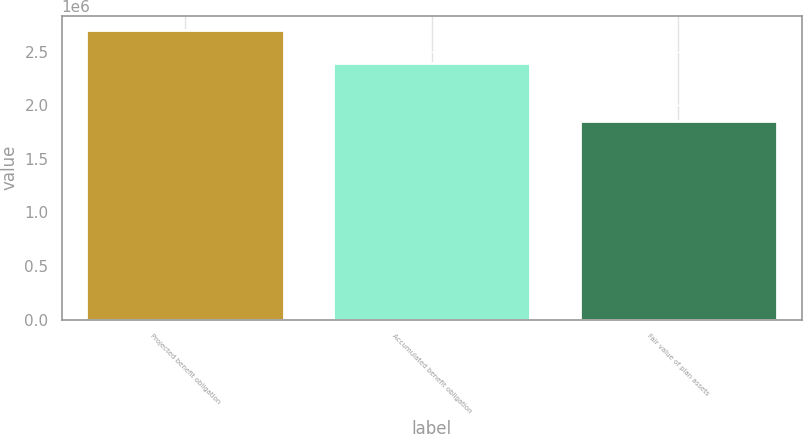Convert chart to OTSL. <chart><loc_0><loc_0><loc_500><loc_500><bar_chart><fcel>Projected benefit obligation<fcel>Accumulated benefit obligation<fcel>Fair value of plan assets<nl><fcel>2.69913e+06<fcel>2.39658e+06<fcel>1.85055e+06<nl></chart> 